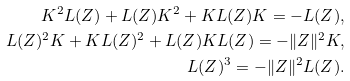<formula> <loc_0><loc_0><loc_500><loc_500>K ^ { 2 } L ( Z ) + L ( Z ) K ^ { 2 } + K L ( Z ) K = - L ( Z ) , \\ L ( Z ) ^ { 2 } K + K L ( Z ) ^ { 2 } + L ( Z ) K L ( Z ) = - \| Z \| ^ { 2 } K , \\ L ( Z ) ^ { 3 } = - \| Z \| ^ { 2 } L ( Z ) .</formula> 